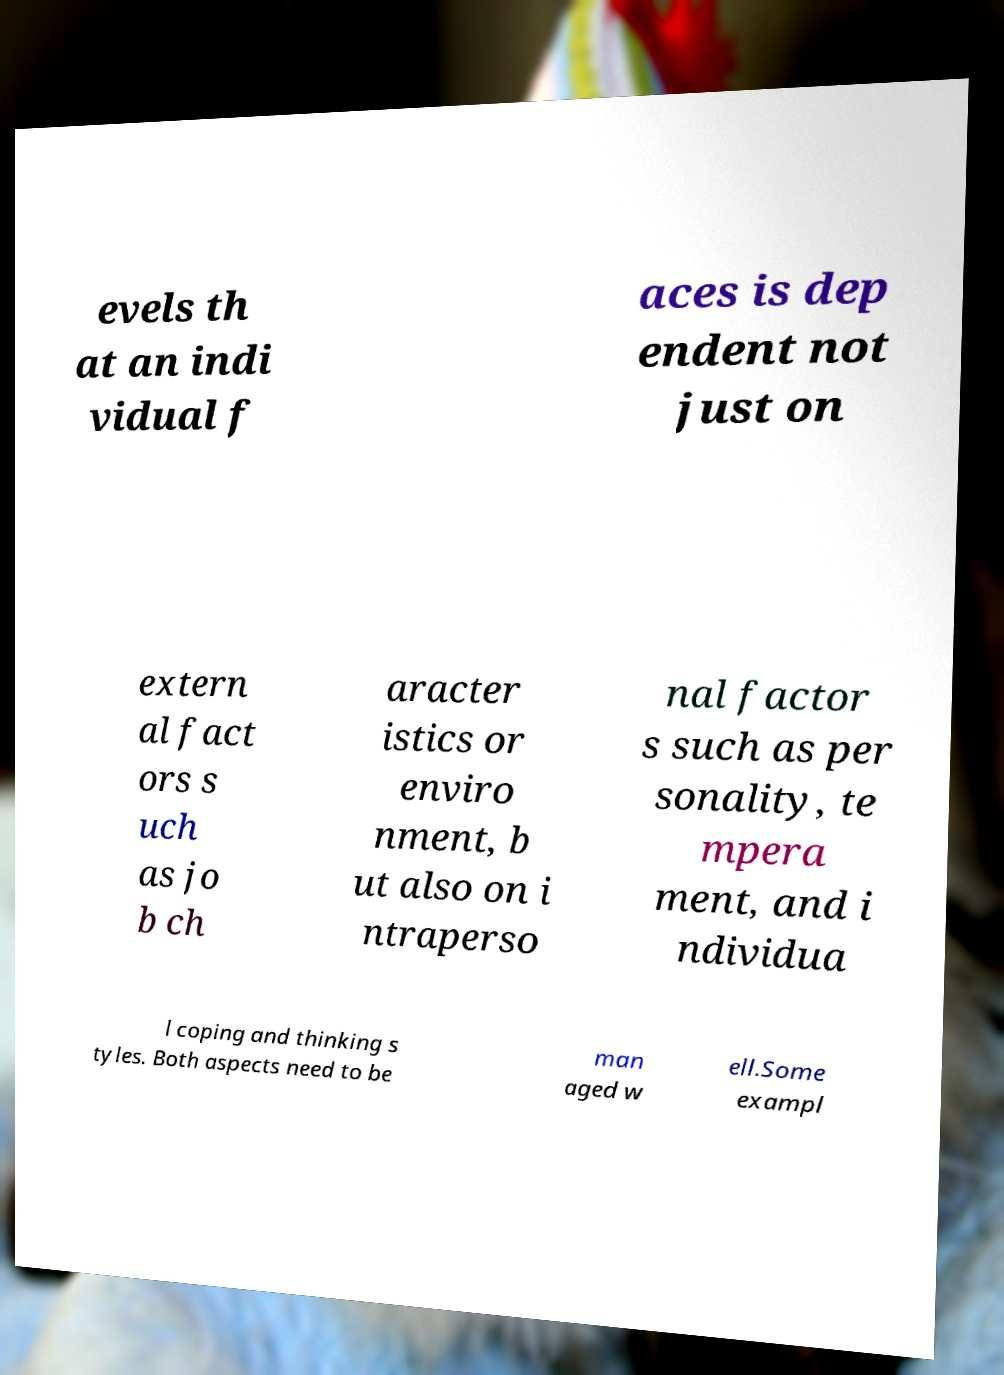There's text embedded in this image that I need extracted. Can you transcribe it verbatim? evels th at an indi vidual f aces is dep endent not just on extern al fact ors s uch as jo b ch aracter istics or enviro nment, b ut also on i ntraperso nal factor s such as per sonality, te mpera ment, and i ndividua l coping and thinking s tyles. Both aspects need to be man aged w ell.Some exampl 